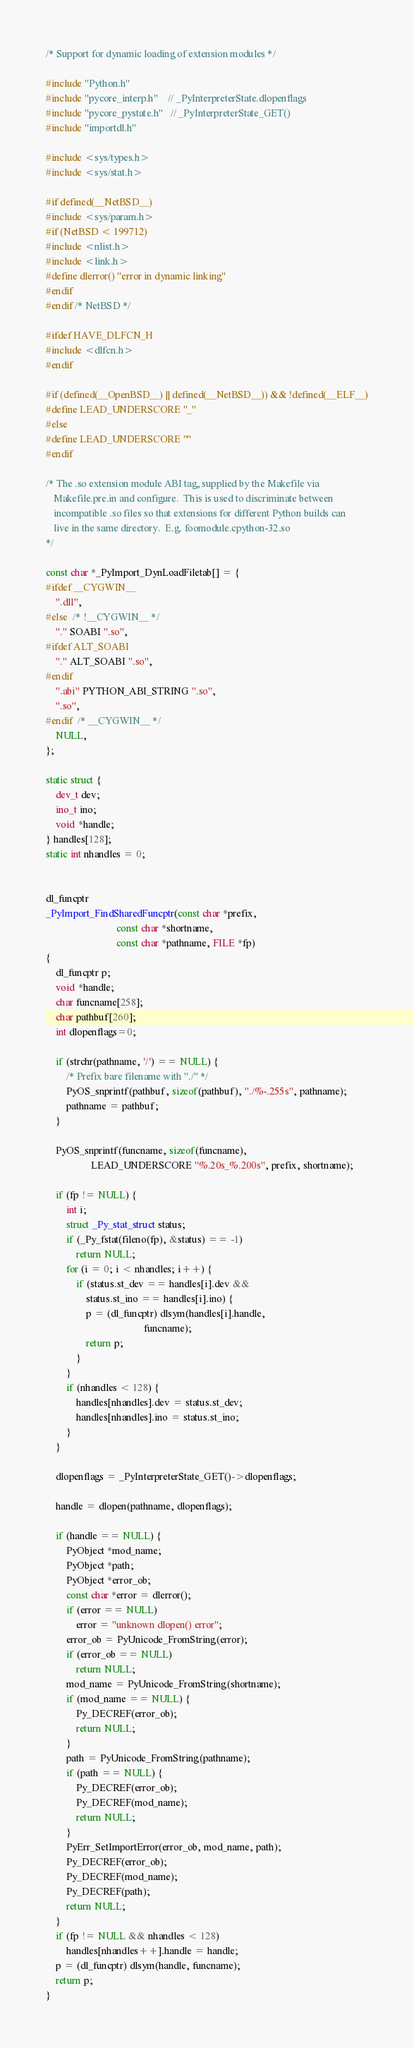Convert code to text. <code><loc_0><loc_0><loc_500><loc_500><_C_>
/* Support for dynamic loading of extension modules */

#include "Python.h"
#include "pycore_interp.h"    // _PyInterpreterState.dlopenflags
#include "pycore_pystate.h"   // _PyInterpreterState_GET()
#include "importdl.h"

#include <sys/types.h>
#include <sys/stat.h>

#if defined(__NetBSD__)
#include <sys/param.h>
#if (NetBSD < 199712)
#include <nlist.h>
#include <link.h>
#define dlerror() "error in dynamic linking"
#endif
#endif /* NetBSD */

#ifdef HAVE_DLFCN_H
#include <dlfcn.h>
#endif

#if (defined(__OpenBSD__) || defined(__NetBSD__)) && !defined(__ELF__)
#define LEAD_UNDERSCORE "_"
#else
#define LEAD_UNDERSCORE ""
#endif

/* The .so extension module ABI tag, supplied by the Makefile via
   Makefile.pre.in and configure.  This is used to discriminate between
   incompatible .so files so that extensions for different Python builds can
   live in the same directory.  E.g. foomodule.cpython-32.so
*/

const char *_PyImport_DynLoadFiletab[] = {
#ifdef __CYGWIN__
    ".dll",
#else  /* !__CYGWIN__ */
    "." SOABI ".so",
#ifdef ALT_SOABI
    "." ALT_SOABI ".so",
#endif
    ".abi" PYTHON_ABI_STRING ".so",
    ".so",
#endif  /* __CYGWIN__ */
    NULL,
};

static struct {
    dev_t dev;
    ino_t ino;
    void *handle;
} handles[128];
static int nhandles = 0;


dl_funcptr
_PyImport_FindSharedFuncptr(const char *prefix,
                            const char *shortname,
                            const char *pathname, FILE *fp)
{
    dl_funcptr p;
    void *handle;
    char funcname[258];
    char pathbuf[260];
    int dlopenflags=0;

    if (strchr(pathname, '/') == NULL) {
        /* Prefix bare filename with "./" */
        PyOS_snprintf(pathbuf, sizeof(pathbuf), "./%-.255s", pathname);
        pathname = pathbuf;
    }

    PyOS_snprintf(funcname, sizeof(funcname),
                  LEAD_UNDERSCORE "%.20s_%.200s", prefix, shortname);

    if (fp != NULL) {
        int i;
        struct _Py_stat_struct status;
        if (_Py_fstat(fileno(fp), &status) == -1)
            return NULL;
        for (i = 0; i < nhandles; i++) {
            if (status.st_dev == handles[i].dev &&
                status.st_ino == handles[i].ino) {
                p = (dl_funcptr) dlsym(handles[i].handle,
                                       funcname);
                return p;
            }
        }
        if (nhandles < 128) {
            handles[nhandles].dev = status.st_dev;
            handles[nhandles].ino = status.st_ino;
        }
    }

    dlopenflags = _PyInterpreterState_GET()->dlopenflags;

    handle = dlopen(pathname, dlopenflags);

    if (handle == NULL) {
        PyObject *mod_name;
        PyObject *path;
        PyObject *error_ob;
        const char *error = dlerror();
        if (error == NULL)
            error = "unknown dlopen() error";
        error_ob = PyUnicode_FromString(error);
        if (error_ob == NULL)
            return NULL;
        mod_name = PyUnicode_FromString(shortname);
        if (mod_name == NULL) {
            Py_DECREF(error_ob);
            return NULL;
        }
        path = PyUnicode_FromString(pathname);
        if (path == NULL) {
            Py_DECREF(error_ob);
            Py_DECREF(mod_name);
            return NULL;
        }
        PyErr_SetImportError(error_ob, mod_name, path);
        Py_DECREF(error_ob);
        Py_DECREF(mod_name);
        Py_DECREF(path);
        return NULL;
    }
    if (fp != NULL && nhandles < 128)
        handles[nhandles++].handle = handle;
    p = (dl_funcptr) dlsym(handle, funcname);
    return p;
}
</code> 